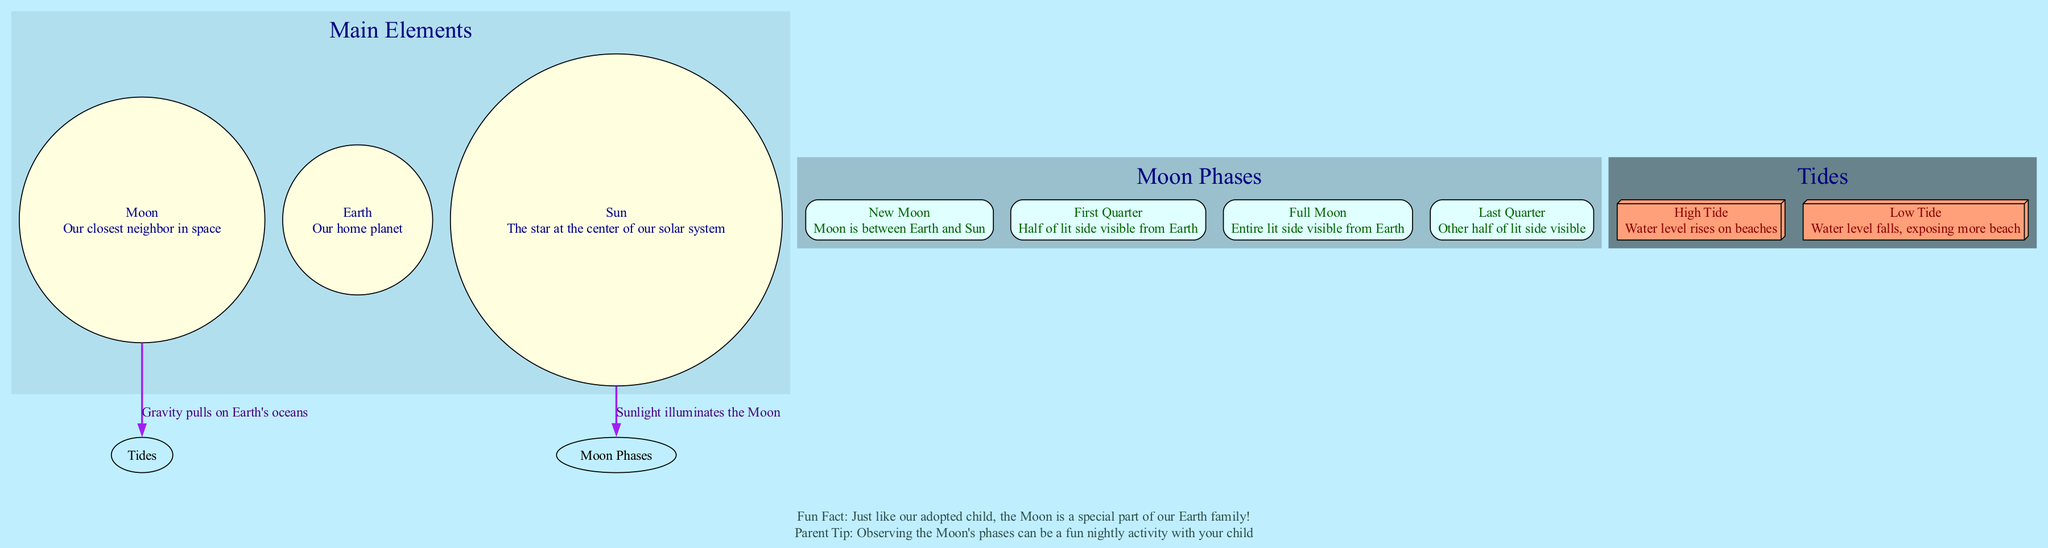What is the name of our closest neighbor in space? The diagram identifies "Moon" as the closest neighbor to Earth in space. This information is found in the main elements section of the diagram, specifically next to the description of the Moon.
Answer: Moon What phase of the moon has the entire lit side visible from Earth? The diagram states that the "Full Moon" phase is when the entire lit side is visible from Earth. This is included in the moon phases section.
Answer: Full Moon What causes the tides on Earth according to the diagram? The diagram indicates that "Gravity pulls on Earth's oceans," which is the connection between the Moon and Tides. This helps explain the cause of the tides in relation to the moon.
Answer: Gravity How many main elements are depicted in the diagram? The diagram lists three main elements: the Moon, Earth, and Sun. This information can be counted from the main elements section.
Answer: 3 Which phase of the moon is described as being between the Earth and the Sun? According to the diagram, the "New Moon" phase is described as occurring when the Moon is between the Earth and the Sun. This detail is part of the moon phases section.
Answer: New Moon What is the water level rise on beaches called? The diagram specifies that the rise in water level on beaches is known as "High Tide," which is found in the tides section.
Answer: High Tide How many moon phases are listed in the diagram? The diagram includes four moon phases: New Moon, First Quarter, Full Moon, and Last Quarter. This can be counted from the moon phases section.
Answer: 4 What illuminates the Moon according to the diagram? The connection between the Sun and Moon phases states that "Sunlight illuminates the Moon." This explains what light reflects off the Moon.
Answer: Sunlight During which phase of the moon is half of the lit side visible from Earth? The diagram notes that during the "First Quarter" phase, half of the lit side of the Moon is visible from Earth. This is detailed in the moon phases section.
Answer: First Quarter 